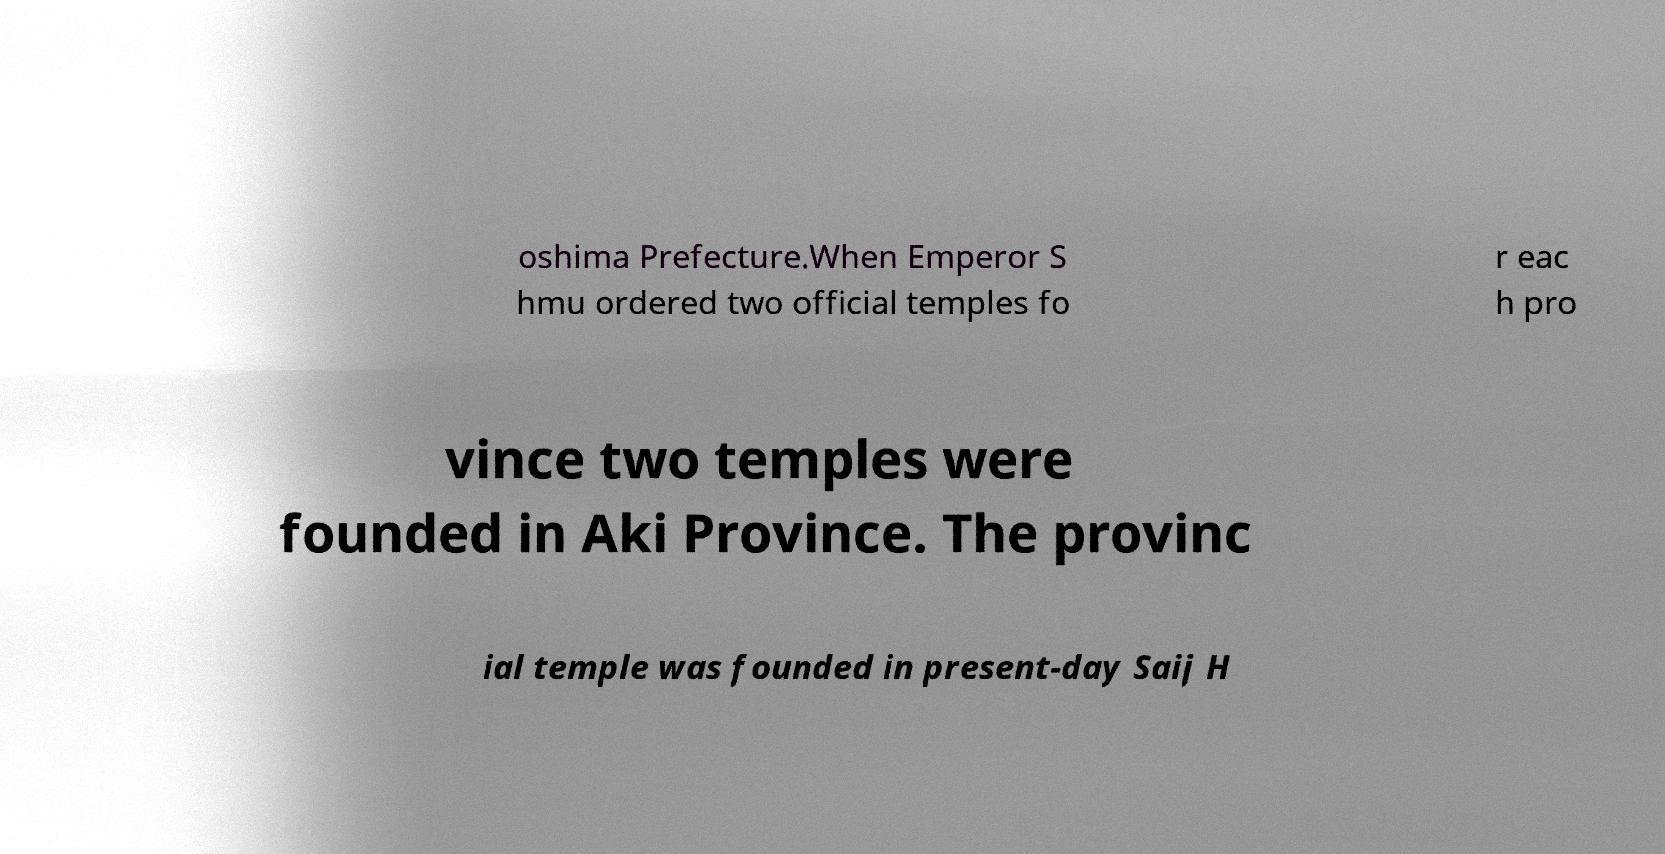Please identify and transcribe the text found in this image. oshima Prefecture.When Emperor S hmu ordered two official temples fo r eac h pro vince two temples were founded in Aki Province. The provinc ial temple was founded in present-day Saij H 